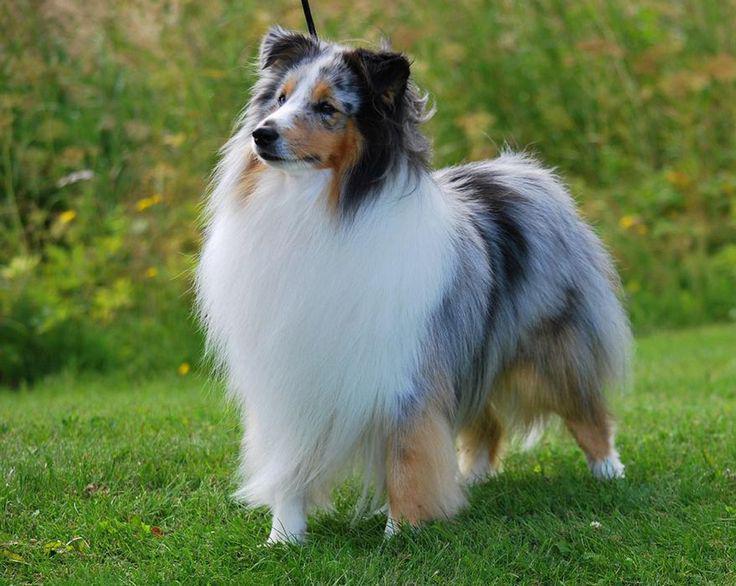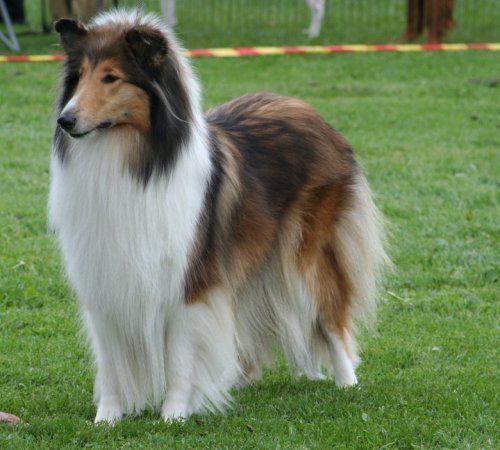The first image is the image on the left, the second image is the image on the right. For the images displayed, is the sentence "In 1 of the images, 1 dog has an open mouth." factually correct? Answer yes or no. No. 